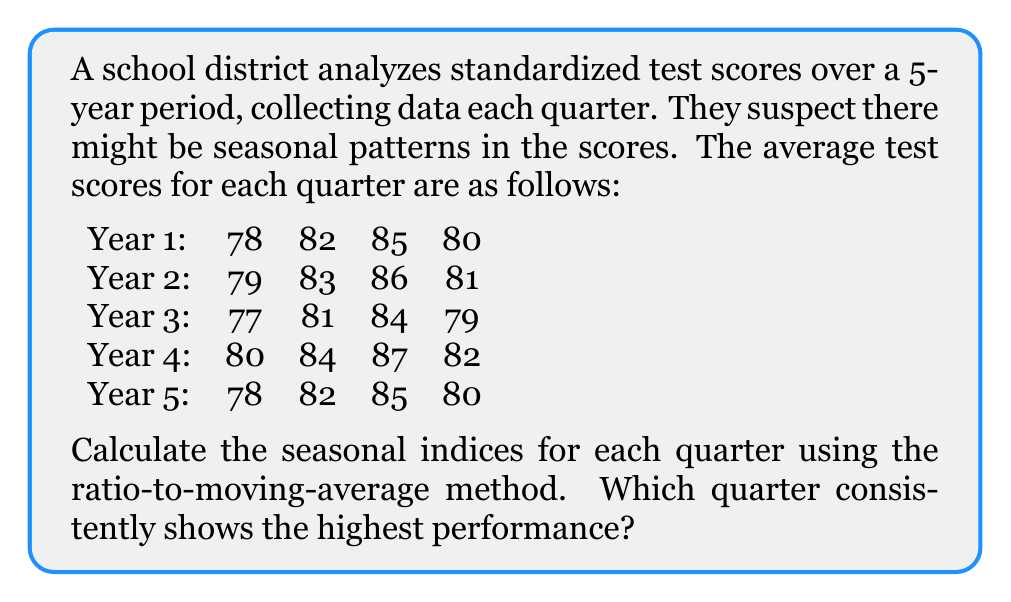Could you help me with this problem? To identify seasonal patterns and calculate seasonal indices, we'll use the ratio-to-moving-average method:

1. Calculate the 4-quarter moving average:
   First, compute the moving totals, then divide by 4.
   
   For example, Year 1 Q4 to Year 2 Q3: $(80 + 79 + 83 + 86) / 4 = 82$

2. Center the moving averages:
   Average two consecutive moving averages.
   
   For example, Year 2 Q1: $(82 + 82.25) / 2 = 82.125$

3. Calculate the ratio of actual value to centered moving average:
   Divide each original value by its corresponding centered moving average.
   
   For example, Year 2 Q1: $79 / 82.125 = 0.9620$

4. Group these ratios by quarter and calculate the average for each quarter:

   Q1: $(0.9620 + 0.9387 + 0.9756 + 0.9503) / 4 = 0.9567$
   Q2: $(1.0126 + 0.9876 + 1.0244 + 1.0000) / 4 = 1.0062$
   Q3: $(1.0474 + 1.0244 + 1.0610 + 1.0366) / 4 = 1.0424$
   Q4: $(0.9864 + 0.9633 + 1.0000 + 0.9756) / 4 = 0.9813$

5. Normalize these averages so they sum to 4 (for quarterly data):
   Multiply each average by $4 / (0.9567 + 1.0062 + 1.0424 + 0.9813) = 1.0035$

   Q1: $0.9567 * 1.0035 = 0.9600$
   Q2: $1.0062 * 1.0035 = 1.0097$
   Q3: $1.0424 * 1.0035 = 1.0461$
   Q4: $0.9813 * 1.0035 = 0.9842$

The seasonal indices show that Q3 consistently has the highest performance with an index of 1.0461, indicating scores in this quarter are typically 4.61% above the annual average.
Answer: The seasonal indices for each quarter are:
Q1: 0.9600
Q2: 1.0097
Q3: 1.0461
Q4: 0.9842

Quarter 3 consistently shows the highest performance with a seasonal index of 1.0461. 